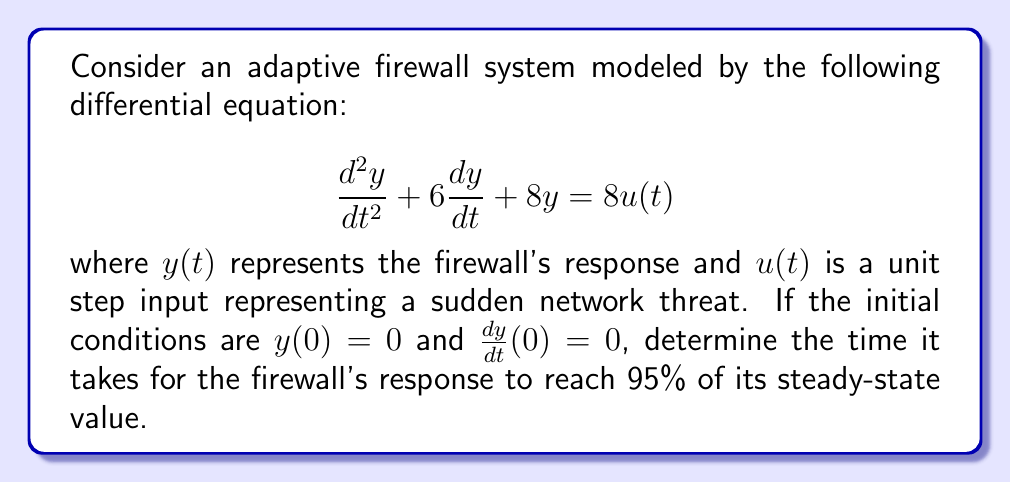Show me your answer to this math problem. To solve this problem, we'll follow these steps:

1) First, we need to find the transfer function of the system. The Laplace transform of the given differential equation is:

   $$s^2Y(s) + 6sY(s) + 8Y(s) = 8U(s)$$

   The transfer function is:

   $$G(s) = \frac{Y(s)}{U(s)} = \frac{8}{s^2 + 6s + 8}$$

2) For a unit step input, $U(s) = \frac{1}{s}$. The output in the s-domain is:

   $$Y(s) = G(s)U(s) = \frac{8}{s(s^2 + 6s + 8)}$$

3) Partial fraction decomposition gives:

   $$Y(s) = \frac{1}{s} - \frac{s+4}{s^2 + 6s + 8}$$

4) Taking the inverse Laplace transform:

   $$y(t) = 1 - e^{-3t}(\cos(t) + 3\sin(t))$$

5) The steady-state value is 1. We need to find $t$ when $y(t) = 0.95$.

6) Solving the equation:

   $$0.95 = 1 - e^{-3t}(\cos(t) + 3\sin(t))$$

   $$0.05 = e^{-3t}(\cos(t) + 3\sin(t))$$

7) This transcendental equation doesn't have a closed-form solution. We need to solve it numerically. Using numerical methods (e.g., Newton-Raphson), we find:

   $$t \approx 1.058$$

Therefore, it takes approximately 1.058 seconds for the firewall's response to reach 95% of its steady-state value.
Answer: The time it takes for the firewall's response to reach 95% of its steady-state value is approximately 1.058 seconds. 